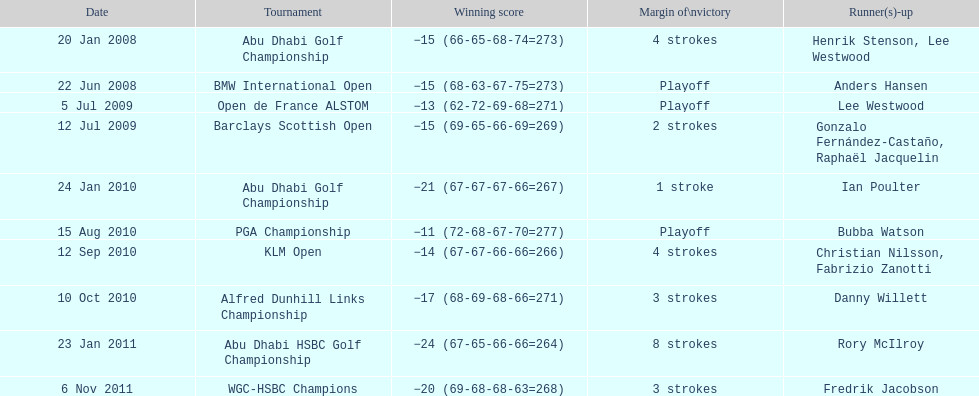How many winning scores were less than -14? 2. 